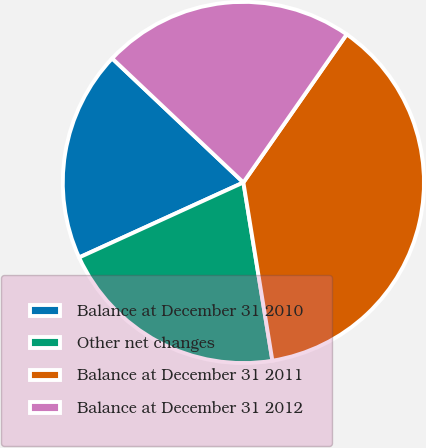<chart> <loc_0><loc_0><loc_500><loc_500><pie_chart><fcel>Balance at December 31 2010<fcel>Other net changes<fcel>Balance at December 31 2011<fcel>Balance at December 31 2012<nl><fcel>18.87%<fcel>20.75%<fcel>37.74%<fcel>22.64%<nl></chart> 